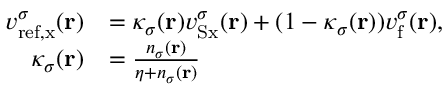<formula> <loc_0><loc_0><loc_500><loc_500>\begin{array} { r l } { v _ { r e f , x } ^ { \sigma } ( r ) } & { = \kappa _ { \sigma } ( r ) v _ { S x } ^ { \sigma } ( r ) + ( 1 - \kappa _ { \sigma } ( r ) ) v _ { f } ^ { \sigma } ( r ) , } \\ { \kappa _ { \sigma } ( r ) } & { = \frac { n _ { \sigma } ( r ) } { \eta + n _ { \sigma } ( r ) } } \end{array}</formula> 